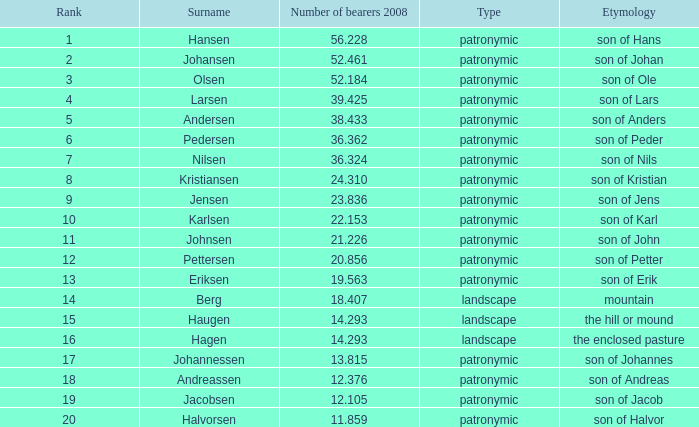What is the largest number of bearers in 2008, when the surname is hansen, and the rank is lesser than 1? None. 